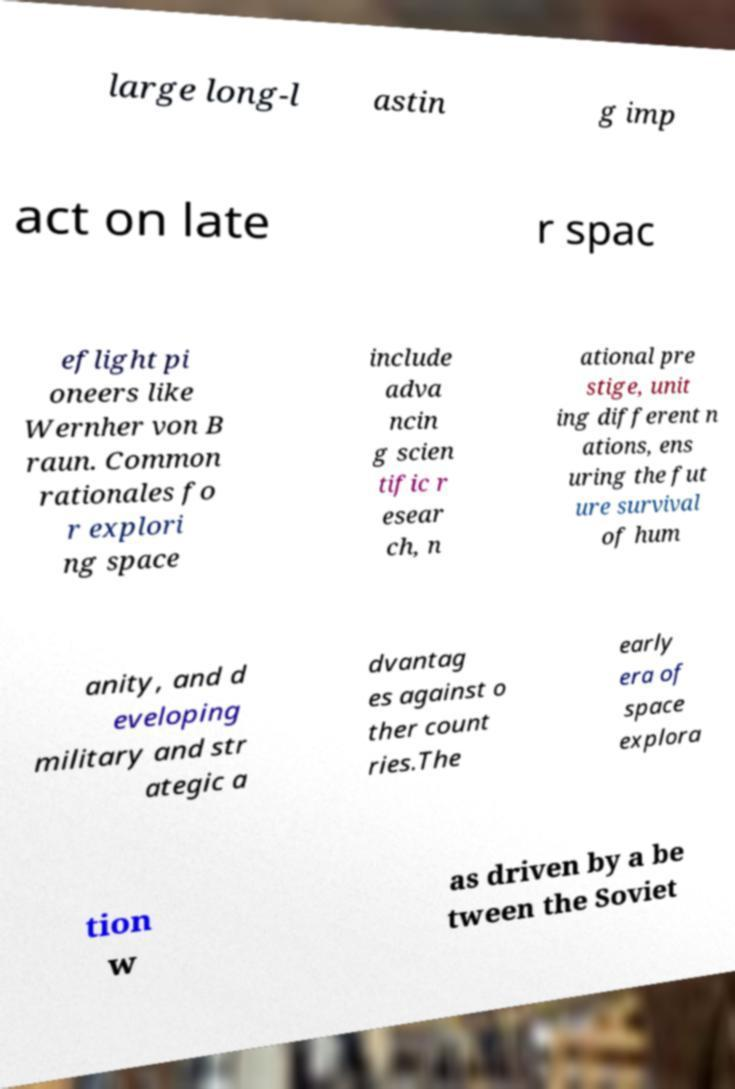Can you accurately transcribe the text from the provided image for me? large long-l astin g imp act on late r spac eflight pi oneers like Wernher von B raun. Common rationales fo r explori ng space include adva ncin g scien tific r esear ch, n ational pre stige, unit ing different n ations, ens uring the fut ure survival of hum anity, and d eveloping military and str ategic a dvantag es against o ther count ries.The early era of space explora tion w as driven by a be tween the Soviet 